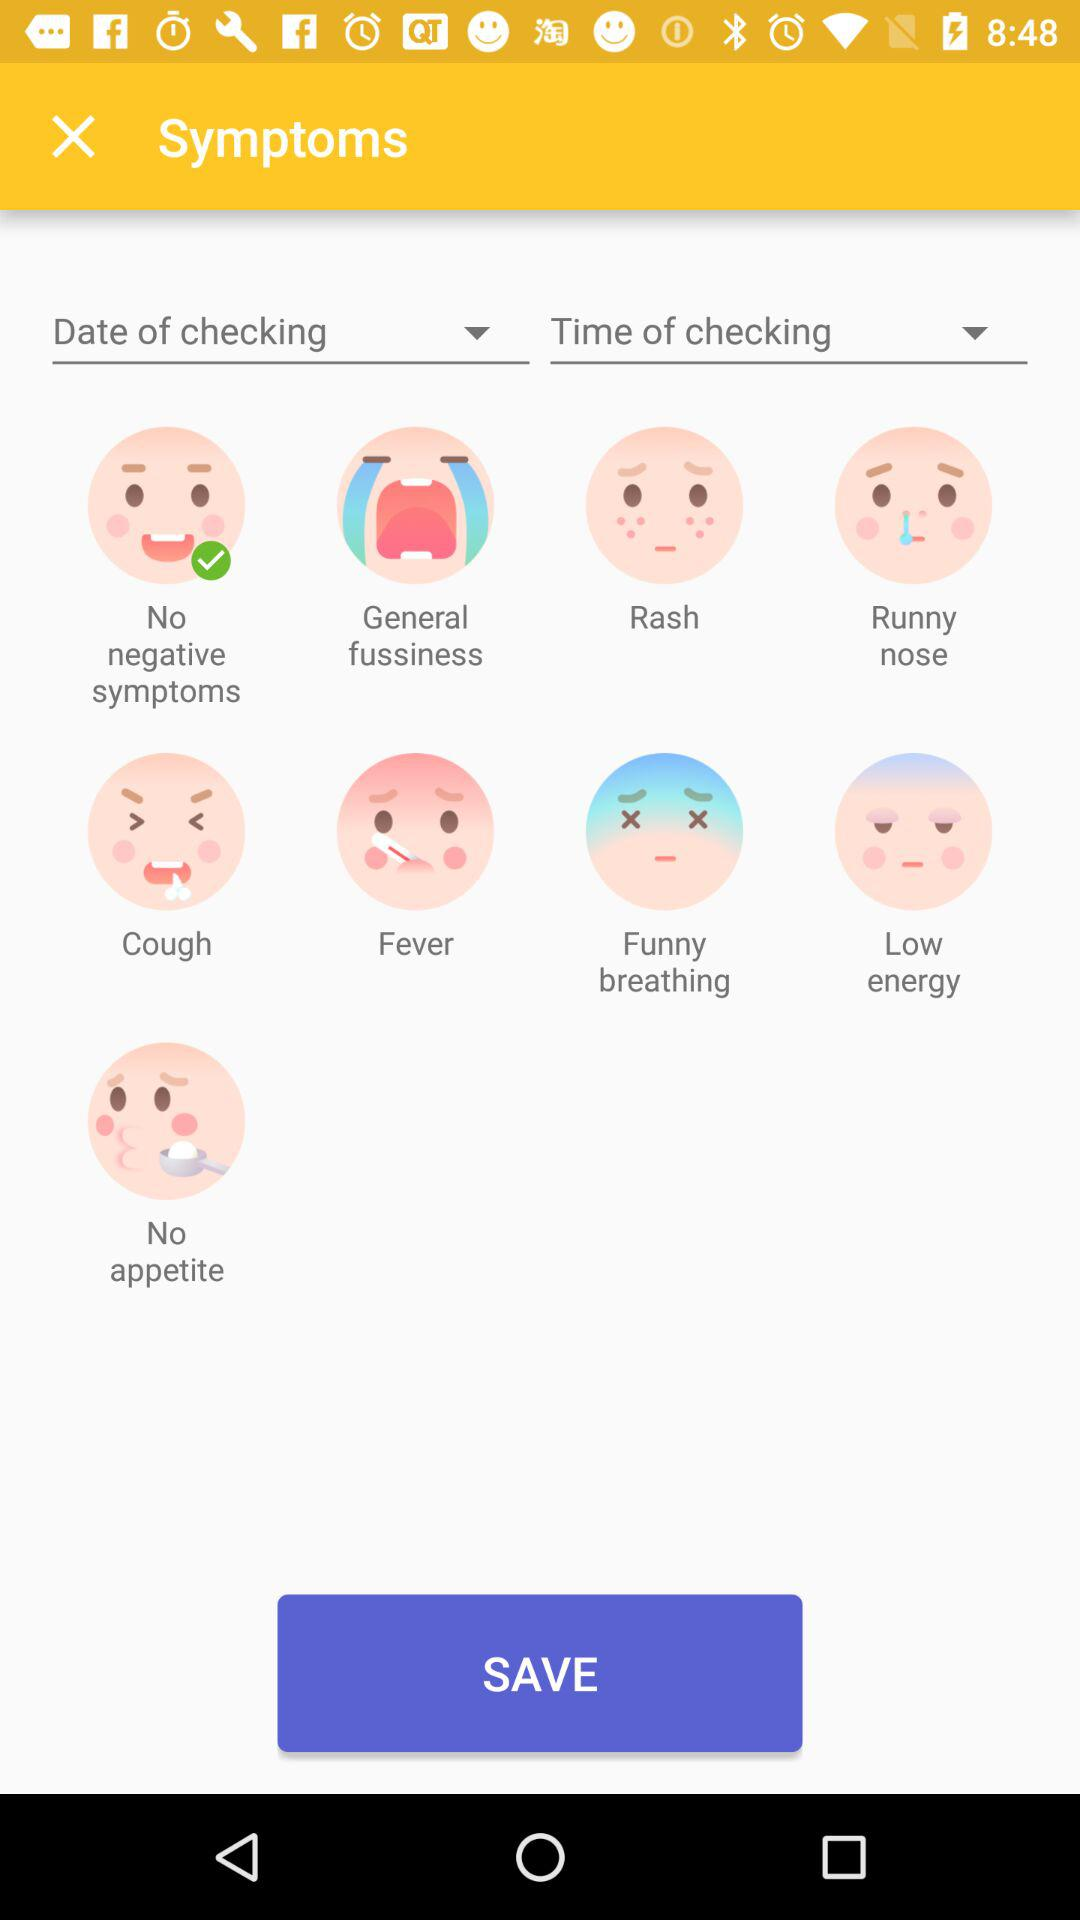Which symptoms are selected? The selected symptom is "No negative symptoms". 